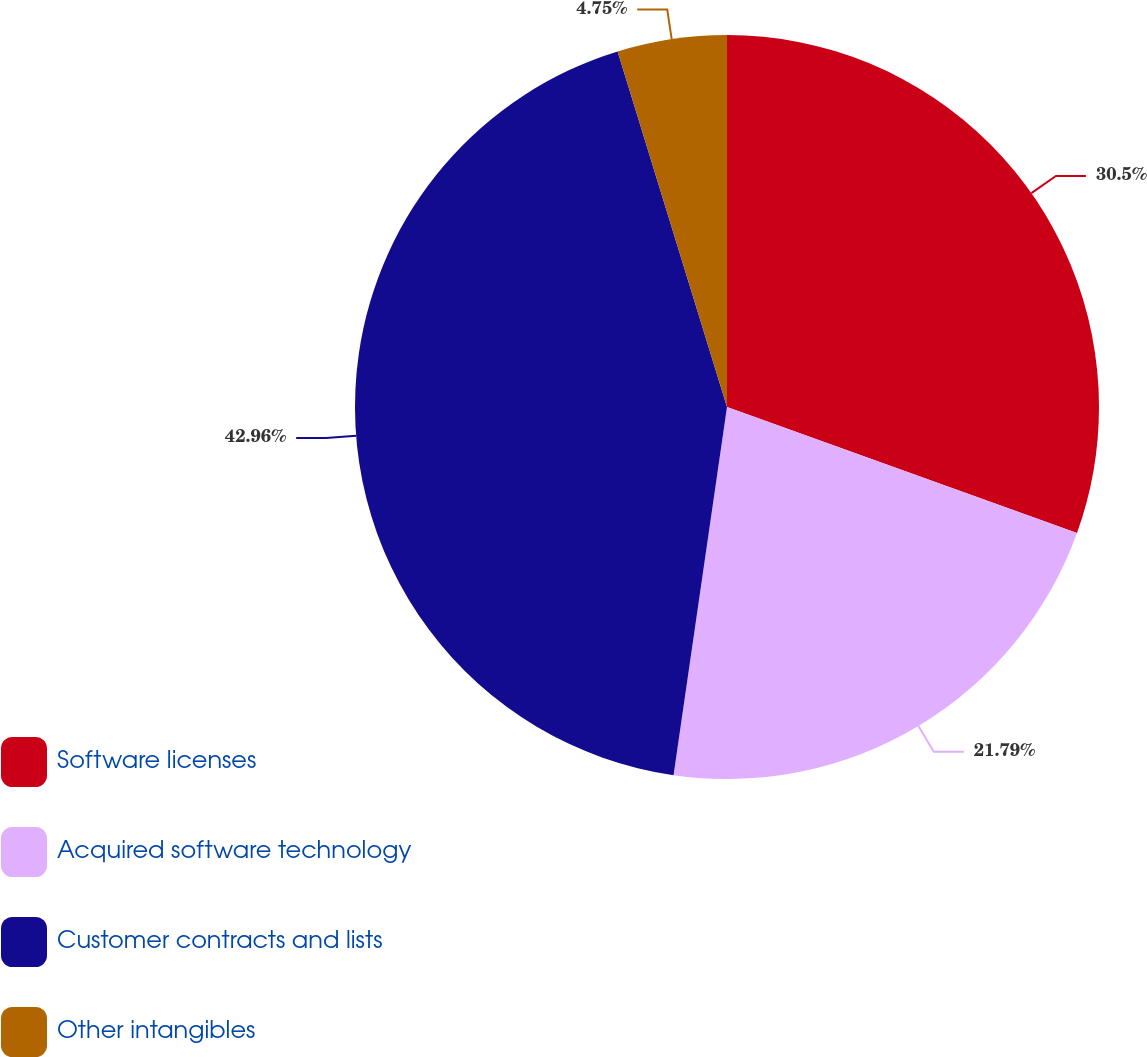Convert chart to OTSL. <chart><loc_0><loc_0><loc_500><loc_500><pie_chart><fcel>Software licenses<fcel>Acquired software technology<fcel>Customer contracts and lists<fcel>Other intangibles<nl><fcel>30.5%<fcel>21.79%<fcel>42.95%<fcel>4.75%<nl></chart> 